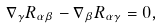<formula> <loc_0><loc_0><loc_500><loc_500>\nabla _ { \gamma } R _ { \alpha \beta } - \nabla _ { \beta } R _ { \alpha \gamma } = 0 ,</formula> 